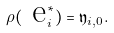<formula> <loc_0><loc_0><loc_500><loc_500>\rho ( \text { e} _ { i } ^ { * } ) = \mathfrak y _ { i , 0 } .</formula> 